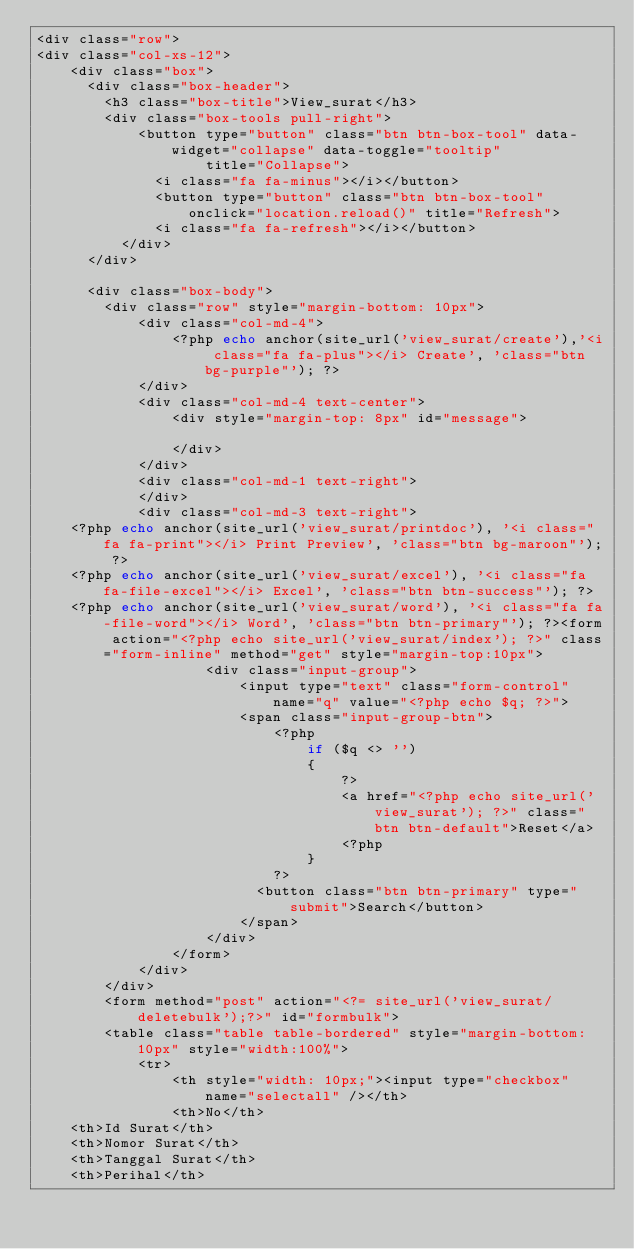<code> <loc_0><loc_0><loc_500><loc_500><_PHP_><div class="row">
<div class="col-xs-12">
    <div class="box">
      <div class="box-header">
        <h3 class="box-title">View_surat</h3>
        <div class="box-tools pull-right">
            <button type="button" class="btn btn-box-tool" data-widget="collapse" data-toggle="tooltip"
                    title="Collapse">
              <i class="fa fa-minus"></i></button>
              <button type="button" class="btn btn-box-tool" onclick="location.reload()" title="Refresh">
              <i class="fa fa-refresh"></i></button>
          </div>
      </div>

      <div class="box-body">
        <div class="row" style="margin-bottom: 10px">
            <div class="col-md-4">
                <?php echo anchor(site_url('view_surat/create'),'<i class="fa fa-plus"></i> Create', 'class="btn bg-purple"'); ?>
            </div>
            <div class="col-md-4 text-center">
                <div style="margin-top: 8px" id="message">
                    
                </div>
            </div>
            <div class="col-md-1 text-right">
            </div>
            <div class="col-md-3 text-right">
		<?php echo anchor(site_url('view_surat/printdoc'), '<i class="fa fa-print"></i> Print Preview', 'class="btn bg-maroon"'); ?>
		<?php echo anchor(site_url('view_surat/excel'), '<i class="fa fa-file-excel"></i> Excel', 'class="btn btn-success"'); ?>
		<?php echo anchor(site_url('view_surat/word'), '<i class="fa fa-file-word"></i> Word', 'class="btn btn-primary"'); ?><form action="<?php echo site_url('view_surat/index'); ?>" class="form-inline" method="get" style="margin-top:10px">
                    <div class="input-group">
                        <input type="text" class="form-control" name="q" value="<?php echo $q; ?>">
                        <span class="input-group-btn">
                            <?php 
                                if ($q <> '')
                                {
                                    ?>
                                    <a href="<?php echo site_url('view_surat'); ?>" class="btn btn-default">Reset</a>
                                    <?php
                                }
                            ?>
                          <button class="btn btn-primary" type="submit">Search</button>
                        </span>
                    </div>
                </form>
            </div>
        </div>
        <form method="post" action="<?= site_url('view_surat/deletebulk');?>" id="formbulk">
        <table class="table table-bordered" style="margin-bottom: 10px" style="width:100%">
            <tr>
                <th style="width: 10px;"><input type="checkbox" name="selectall" /></th>
                <th>No</th>
		<th>Id Surat</th>
		<th>Nomor Surat</th>
		<th>Tanggal Surat</th>
		<th>Perihal</th></code> 